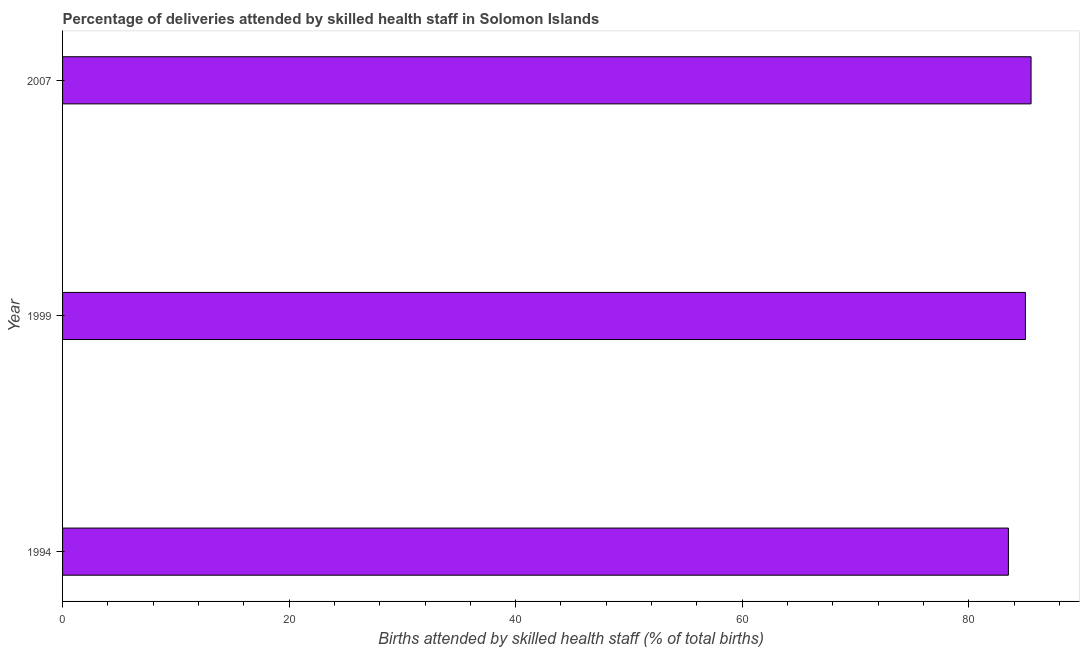Does the graph contain grids?
Offer a terse response. No. What is the title of the graph?
Give a very brief answer. Percentage of deliveries attended by skilled health staff in Solomon Islands. What is the label or title of the X-axis?
Give a very brief answer. Births attended by skilled health staff (% of total births). What is the number of births attended by skilled health staff in 1994?
Your answer should be compact. 83.5. Across all years, what is the maximum number of births attended by skilled health staff?
Provide a short and direct response. 85.5. Across all years, what is the minimum number of births attended by skilled health staff?
Make the answer very short. 83.5. In which year was the number of births attended by skilled health staff minimum?
Your answer should be compact. 1994. What is the sum of the number of births attended by skilled health staff?
Make the answer very short. 254. What is the average number of births attended by skilled health staff per year?
Your response must be concise. 84.67. Do a majority of the years between 1994 and 2007 (inclusive) have number of births attended by skilled health staff greater than 16 %?
Make the answer very short. Yes. What is the ratio of the number of births attended by skilled health staff in 1994 to that in 2007?
Provide a succinct answer. 0.98. Is the number of births attended by skilled health staff in 1999 less than that in 2007?
Offer a terse response. Yes. What is the difference between the highest and the second highest number of births attended by skilled health staff?
Provide a succinct answer. 0.5. In how many years, is the number of births attended by skilled health staff greater than the average number of births attended by skilled health staff taken over all years?
Provide a succinct answer. 2. How many bars are there?
Make the answer very short. 3. Are all the bars in the graph horizontal?
Your response must be concise. Yes. What is the Births attended by skilled health staff (% of total births) of 1994?
Keep it short and to the point. 83.5. What is the Births attended by skilled health staff (% of total births) in 1999?
Your answer should be very brief. 85. What is the Births attended by skilled health staff (% of total births) of 2007?
Provide a succinct answer. 85.5. What is the difference between the Births attended by skilled health staff (% of total births) in 1994 and 1999?
Keep it short and to the point. -1.5. What is the ratio of the Births attended by skilled health staff (% of total births) in 1994 to that in 1999?
Your answer should be very brief. 0.98. What is the ratio of the Births attended by skilled health staff (% of total births) in 1994 to that in 2007?
Offer a very short reply. 0.98. What is the ratio of the Births attended by skilled health staff (% of total births) in 1999 to that in 2007?
Your answer should be compact. 0.99. 